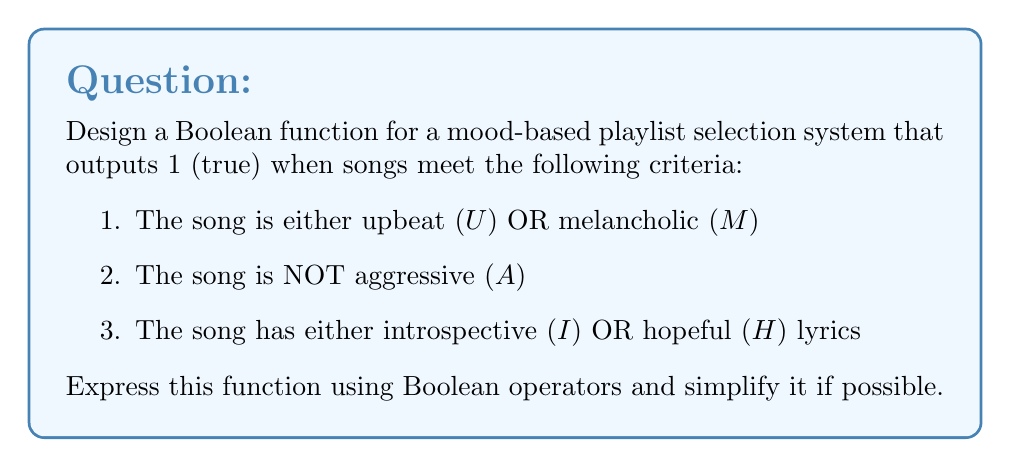Can you answer this question? Let's approach this step-by-step:

1) First, let's translate each condition into Boolean expressions:
   - Condition 1: $U \lor M$
   - Condition 2: $\lnot A$
   - Condition 3: $I \lor H$

2) Now, we need to combine these conditions using the AND operator ($\land$) since all conditions must be met:

   $F = (U \lor M) \land (\lnot A) \land (I \lor H)$

3) This expression is already in its simplest form, as we can't apply any Boolean algebra laws to simplify it further. The function $F$ will return 1 (true) when all three conditions are met, and 0 (false) otherwise.

4) To interpret this function in the context of the persona:
   - The musician can select songs that match their current mood (upbeat or melancholic)
   - They avoid aggressive songs, which might not be helpful for their mental health
   - The lyrics should be either introspective (allowing for self-reflection) or hopeful (providing encouragement)

This Boolean function allows the musician to create a playlist that aligns with their emotional state and supports their mental health journey through carefully selected music.
Answer: $F = (U \lor M) \land (\lnot A) \land (I \lor H)$ 